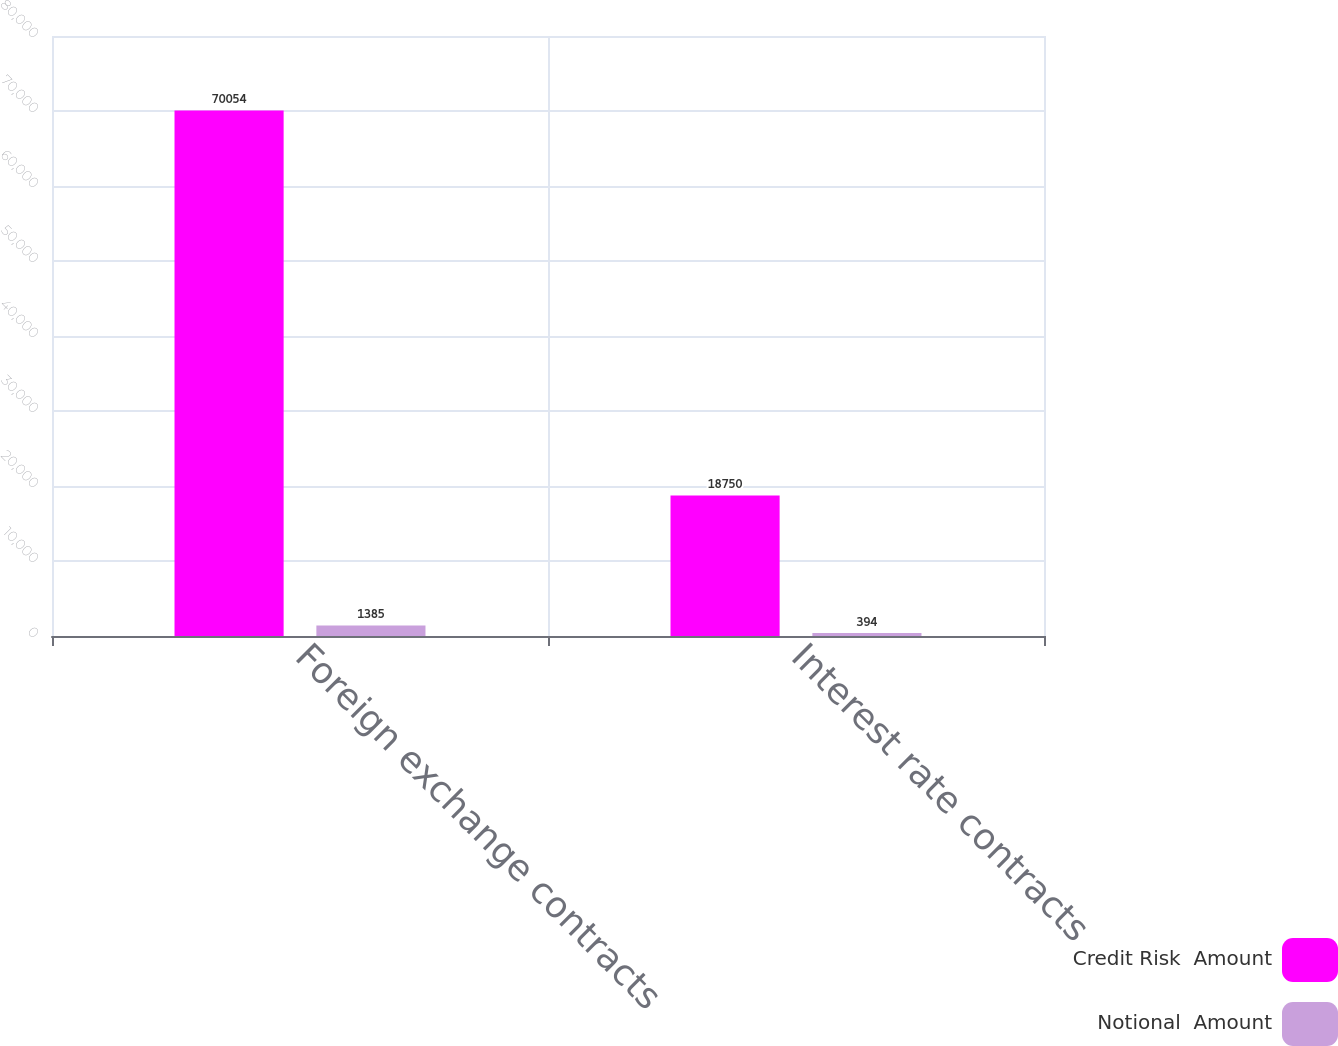Convert chart. <chart><loc_0><loc_0><loc_500><loc_500><stacked_bar_chart><ecel><fcel>Foreign exchange contracts<fcel>Interest rate contracts<nl><fcel>Credit Risk  Amount<fcel>70054<fcel>18750<nl><fcel>Notional  Amount<fcel>1385<fcel>394<nl></chart> 